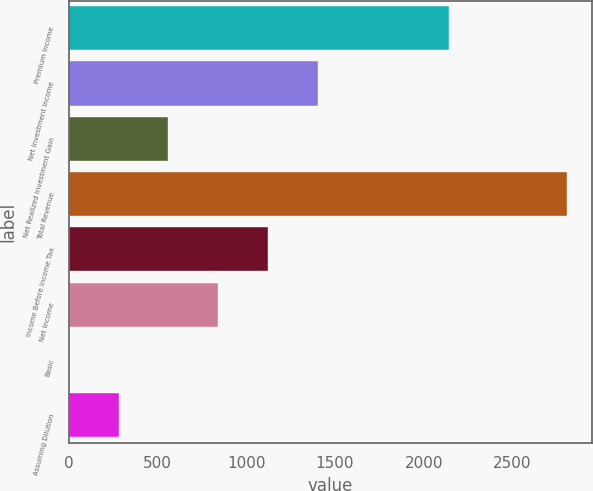Convert chart to OTSL. <chart><loc_0><loc_0><loc_500><loc_500><bar_chart><fcel>Premium Income<fcel>Net Investment Income<fcel>Net Realized Investment Gain<fcel>Total Revenue<fcel>Income Before Income Tax<fcel>Net Income<fcel>Basic<fcel>Assuming Dilution<nl><fcel>2142.9<fcel>1403.75<fcel>562.1<fcel>2806.5<fcel>1123.2<fcel>842.65<fcel>1<fcel>281.55<nl></chart> 